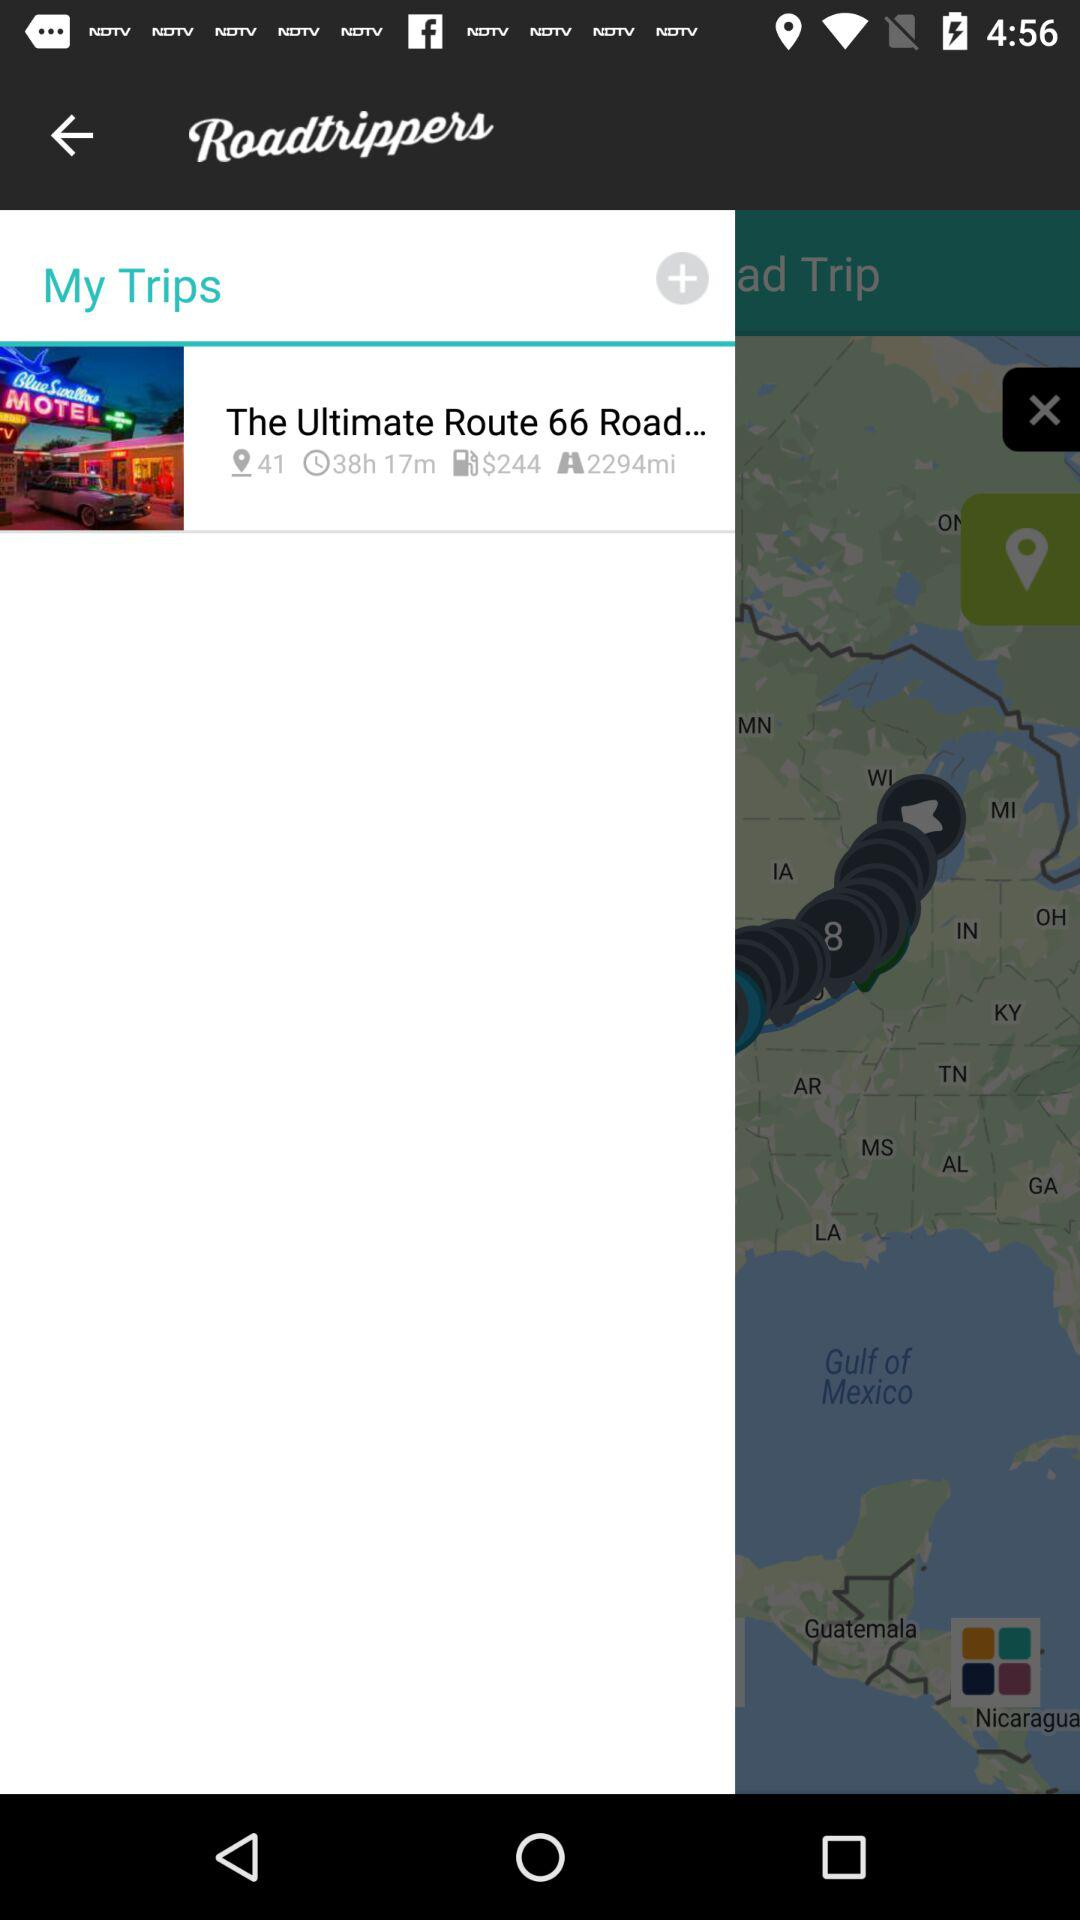What is the application name? The application name is "Roadtrippers". 